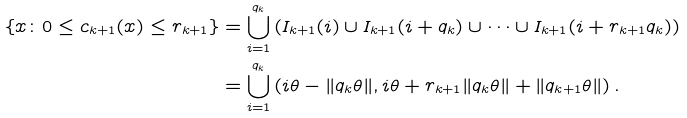Convert formula to latex. <formula><loc_0><loc_0><loc_500><loc_500>\{ x \colon 0 \leq c _ { k + 1 } ( x ) \leq r _ { k + 1 } \} & = \bigcup _ { i = 1 } ^ { q _ { k } } \left ( I _ { k + 1 } ( i ) \cup I _ { k + 1 } ( i + q _ { k } ) \cup \dots \cup I _ { k + 1 } ( i + r _ { k + 1 } q _ { k } ) \right ) \\ & = \bigcup _ { i = 1 } ^ { q _ { k } } \left ( i \theta - \| q _ { k } \theta \| , i \theta + r _ { k + 1 } \| q _ { k } \theta \| + \| q _ { k + 1 } \theta \| \right ) .</formula> 